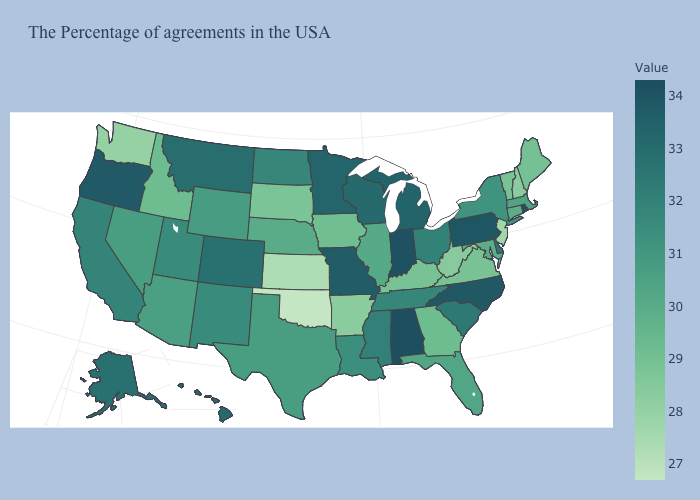Which states have the lowest value in the Northeast?
Answer briefly. New Jersey. Does Alabama have the highest value in the USA?
Write a very short answer. Yes. Does New York have the lowest value in the Northeast?
Give a very brief answer. No. Does the map have missing data?
Keep it brief. No. Which states have the highest value in the USA?
Write a very short answer. Alabama. 